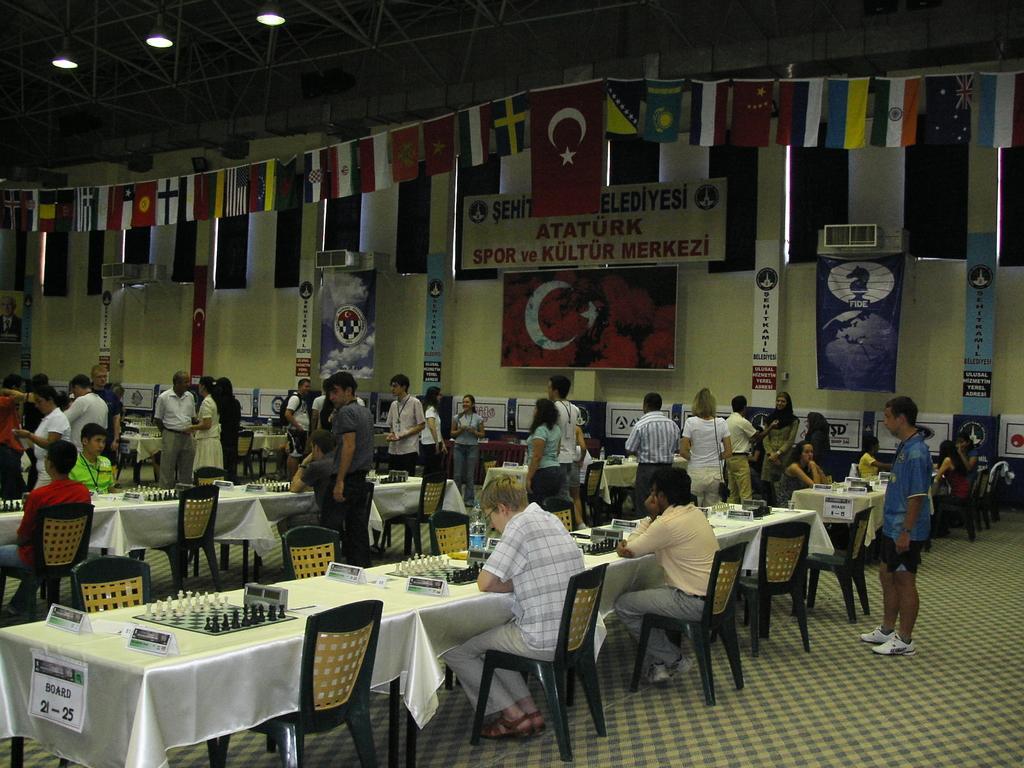Can you describe this image briefly? In this image I can see number of people were few of them are sitting and few of them are standing. In the background I can see flags of different countries. 